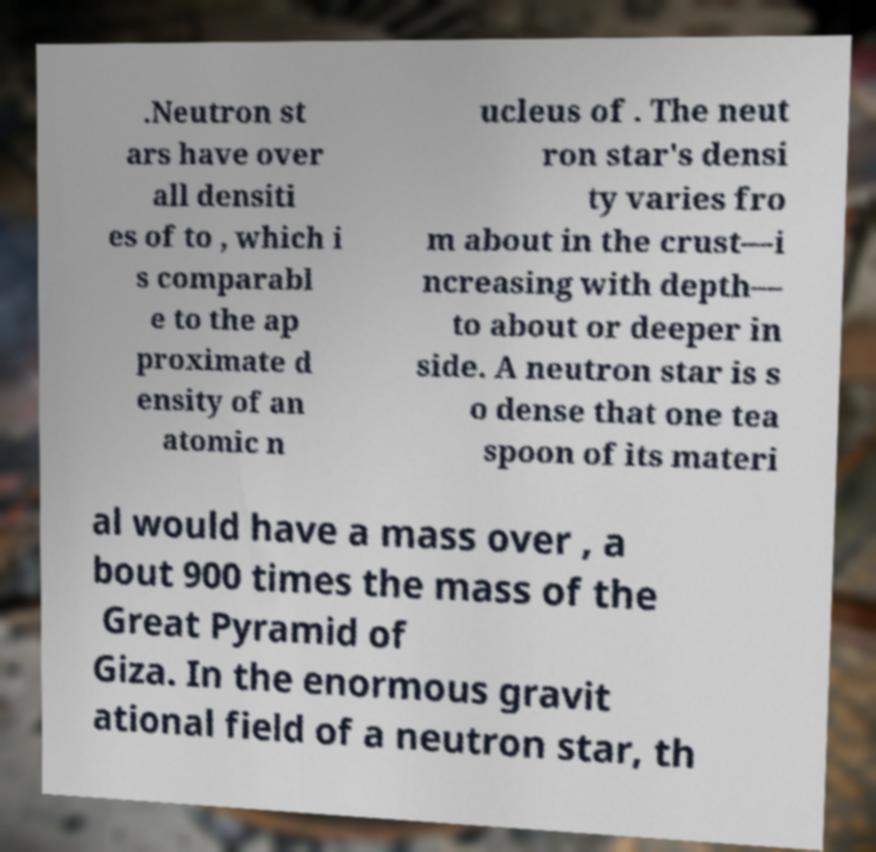There's text embedded in this image that I need extracted. Can you transcribe it verbatim? .Neutron st ars have over all densiti es of to , which i s comparabl e to the ap proximate d ensity of an atomic n ucleus of . The neut ron star's densi ty varies fro m about in the crust—i ncreasing with depth— to about or deeper in side. A neutron star is s o dense that one tea spoon of its materi al would have a mass over , a bout 900 times the mass of the Great Pyramid of Giza. In the enormous gravit ational field of a neutron star, th 